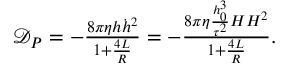Convert formula to latex. <formula><loc_0><loc_0><loc_500><loc_500>\begin{array} { r } { \mathcal { D } _ { P } = - \frac { 8 \pi \eta h \dot { h } ^ { 2 } } { 1 + \frac { 4 L } { R } } = - \frac { 8 \pi \eta \frac { h _ { 0 } ^ { 3 } } { \tau ^ { 2 } } H H ^ { 2 } } { 1 + \frac { 4 L } { R } } . } \end{array}</formula> 